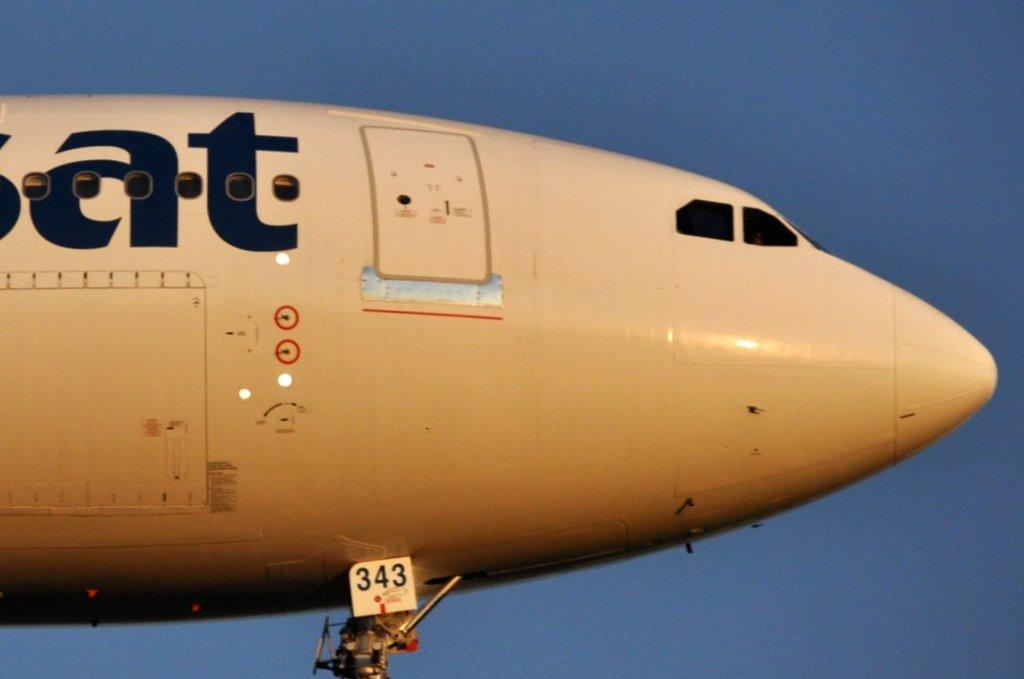What is the main subject of the image? The main subject of the image is an aeroplane. What is the aeroplane doing in the image? The aeroplane is flying in the sky. Can you see any animals exchanging goods on a farm in the image? There are no animals or farms present in the image; it features an aeroplane flying in the sky. What type of shake is being prepared in the image? There is no shake being prepared in the image; it only shows an aeroplane flying in the sky. 